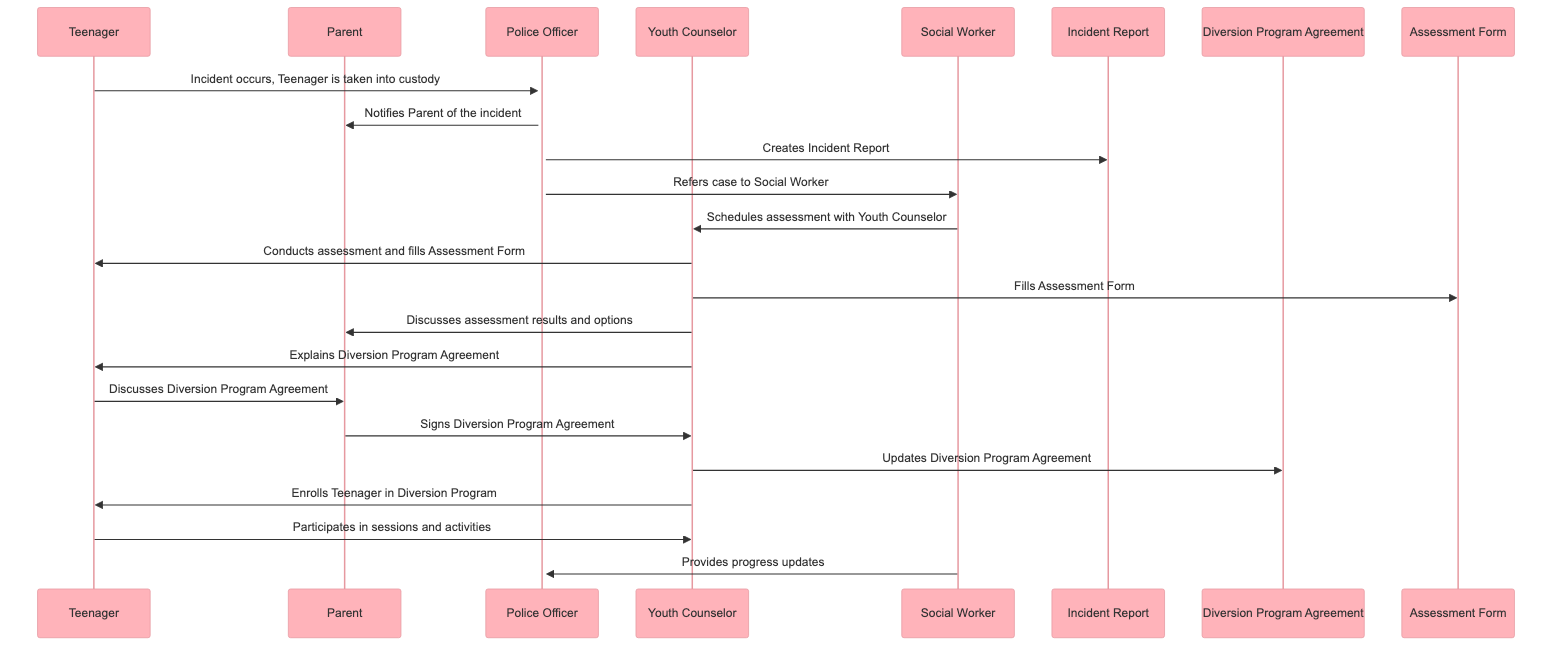What is the first action taken in the sequence? The first action in the sequence is the Teenager being taken into custody by the Police Officer, which initiates the process.
Answer: Incident occurs, Teenager is taken into custody How many documents are referenced in the diagram? The diagram references three documents: the Incident Report, the Diversion Program Agreement, and the Assessment Form.
Answer: 3 Who discusses the assessment results with the Parent? The Youth Counselor discusses the assessment results and options with the Parent, providing crucial information for decision-making.
Answer: Youth Counselor What does the Teenager do after discussing the Diversion Program Agreement with the Parent? After discussing the Diversion Program Agreement, the Teenager participates in sessions and activities as part of the program.
Answer: Participates in sessions and activities Which official is responsible for referring the case to the Social Worker? The Police Officer is responsible for referring the case to the Social Worker, indicating the next step in the process of addressing the incident.
Answer: Police Officer What document does the Youth Counselor fill during the assessment? The Youth Counselor fills the Assessment Form during the assessment process with the Teenager, capturing essential information for evaluation.
Answer: Assessment Form Who provides progress updates to the Police Officer? The Social Worker is responsible for providing progress updates to the Police Officer, ensuring that law enforcement stays informed about the Teenager's development in the program.
Answer: Social Worker How many times does the Teenager interact with the Youth Counselor in the diagram? The Teenager interacts with the Youth Counselor at least three times: during the assessment, when they are being explained the Diversion Program Agreement, and while participating in sessions.
Answer: At least 3 times What is the final action taken by the Youth Counselor in the sequence? The final action taken by the Youth Counselor is enrolling the Teenager in the Diversion Program, marking the completion of the intake process.
Answer: Enrolls Teenager in Diversion Program 